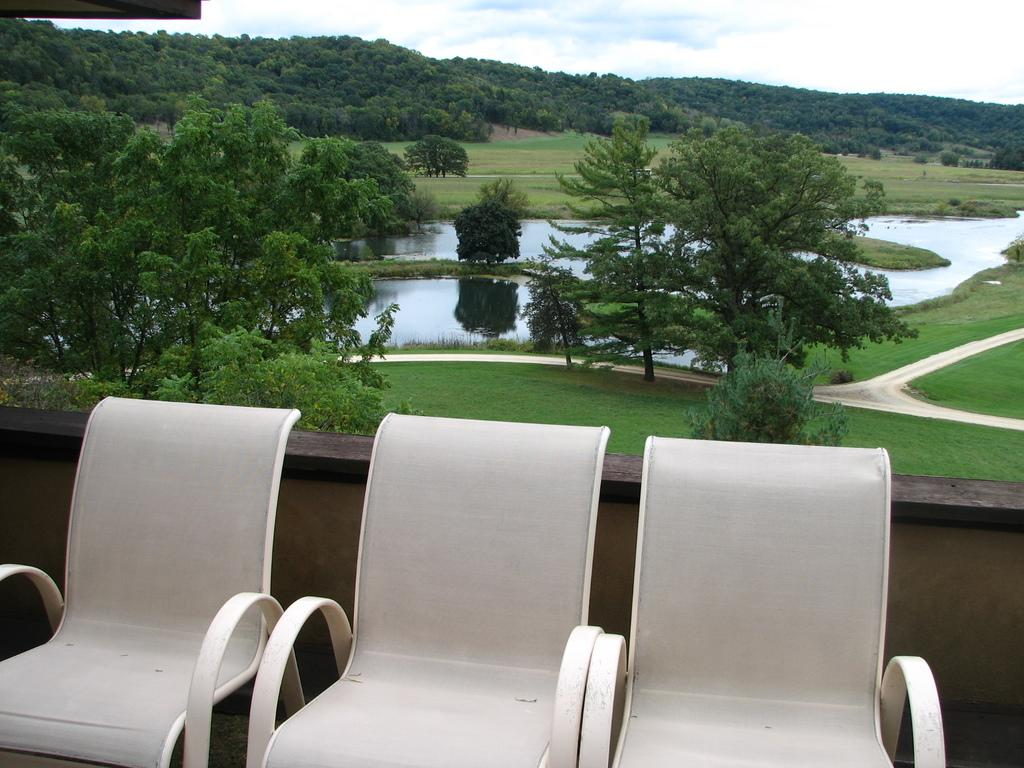How many white chairs are in the image? There are three white chairs in the image. What can be seen in the background of the image? There are trees, grass, and water visible in the background of the image. How many cars are parked on the roof in the image? There are no cars or roof present in the image. 